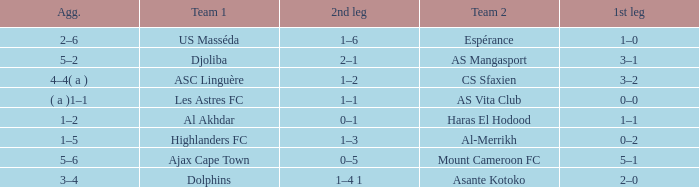What is the 2nd leg of team 1 Dolphins? 1–4 1. 